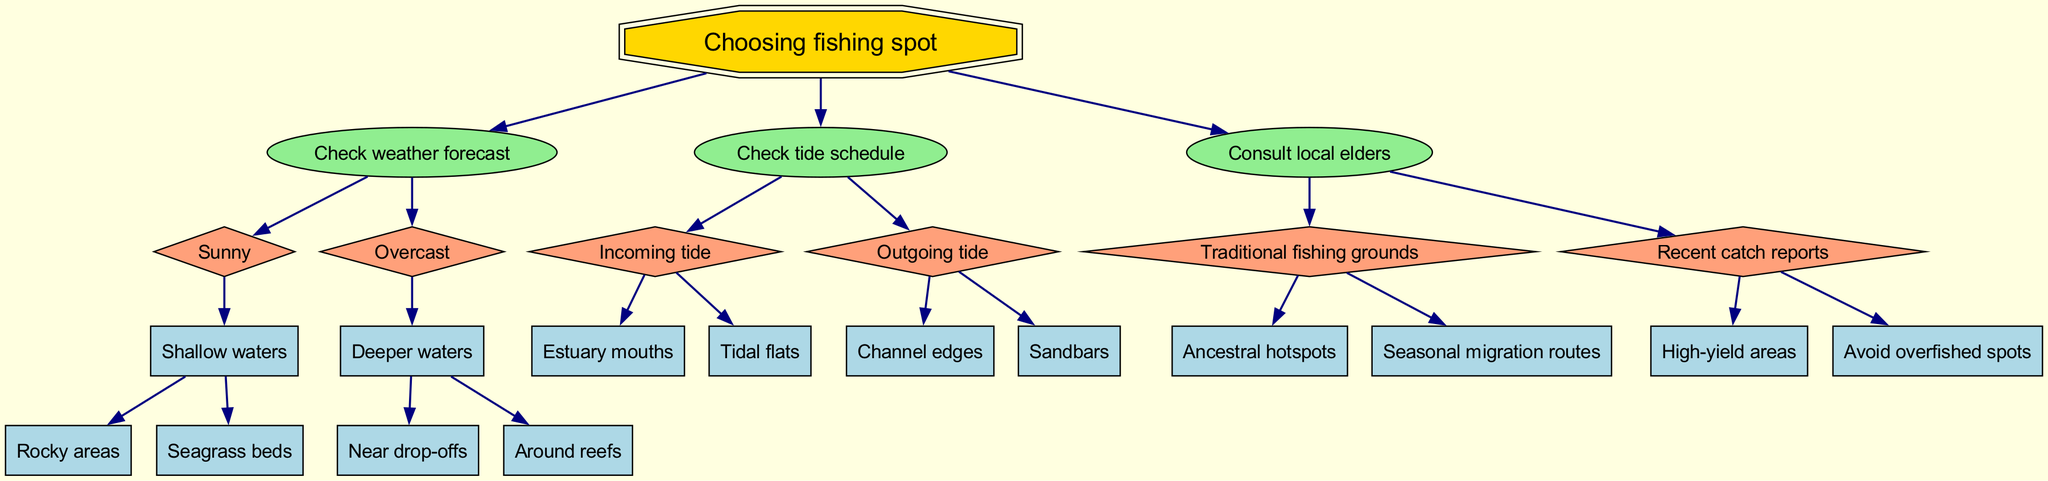What is the first step to take when choosing a fishing spot? The diagram starts with the root node labeled "Choosing fishing spot," which points to three main actions: "Check weather forecast," "Check tide schedule," and "Consult local elders." The first action listed is "Check weather forecast."
Answer: Check weather forecast How many child nodes does "Check weather forecast" have? The node "Check weather forecast" has two child nodes: "Sunny" and "Overcast." Thus, it has a total of two children.
Answer: 2 What spot should be considered under 'Sunny' weather and 'Shallow waters'? Following the path in the diagram, under “Sunny” weather and “Shallow waters,” the available spots are “Rocky areas” and “Seagrass beds.”
Answer: Rocky areas, Seagrass beds What should be checked if the tide is outgoing? The "Check tide schedule" node has "Outgoing tide" as a branch which leads to two locations: "Channel edges" and "Sandbars.” Therefore, if the tide is outgoing, these spots should be considered.
Answer: Channel edges, Sandbars Which action should be taken first if consulting local knowledge? According to the flow of the diagram, after choosing to "Consult local elders," one can choose either "Traditional fishing grounds" or "Recent catch reports." The initial action is deciding to consult locals.
Answer: Consult local elders What type of spots come under "Traditional fishing grounds"? The "Traditional fishing grounds" node has two further branches leading to "Ancestral hotspots" and "Seasonal migration routes." Thus, these are the two types of spots included under this category.
Answer: Ancestral hotspots, Seasonal migration routes If the weather is overcast, where should I fish? In the pathway for “Overcast” weather, the diagram suggests going to “Deeper waters,” which further leads to options like “Near drop-offs” and “Around reefs.” Therefore, if the weather is overcast, those are the recommended fishing locations.
Answer: Near drop-offs, Around reefs How many total nodes are present in the decision tree? The tree has a root node and ten additional nodes (three main nodes with children). Summing these gives a total of eleven nodes in the diagram.
Answer: 11 Which child node leads to "Avoid overfished spots"? Tracing the route in the diagram, the child node that leads to “Avoid overfished spots” is found under "Consult local elders" and the branch titled "Recent catch reports."
Answer: Recent catch reports 